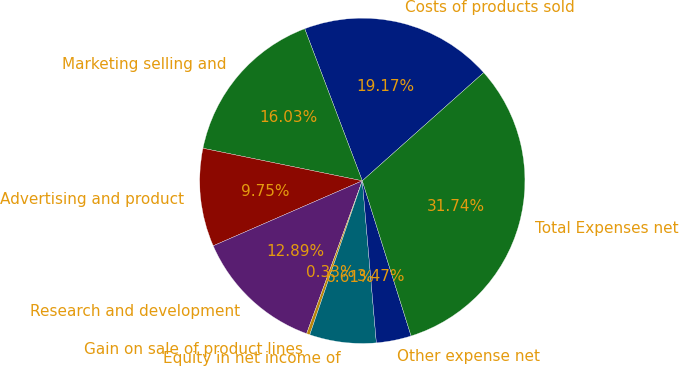<chart> <loc_0><loc_0><loc_500><loc_500><pie_chart><fcel>Costs of products sold<fcel>Marketing selling and<fcel>Advertising and product<fcel>Research and development<fcel>Gain on sale of product lines<fcel>Equity in net income of<fcel>Other expense net<fcel>Total Expenses net<nl><fcel>19.17%<fcel>16.03%<fcel>9.75%<fcel>12.89%<fcel>0.33%<fcel>6.61%<fcel>3.47%<fcel>31.73%<nl></chart> 